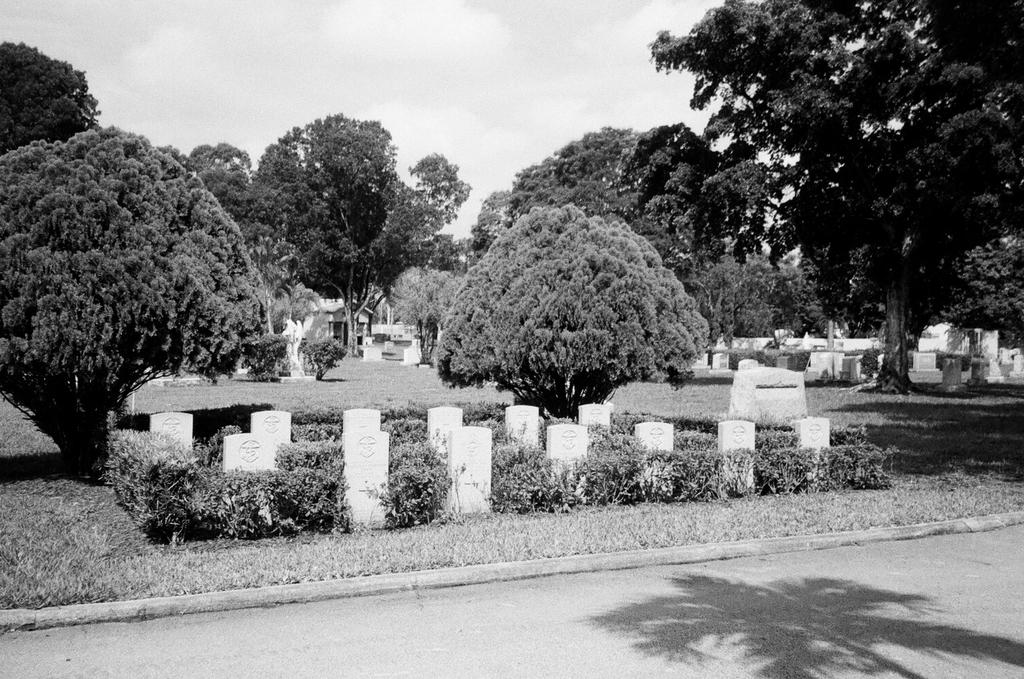What type of location is depicted in the image? There is a graveyard in the image. What can be found within the graveyard? There are graves in the graveyard. What type of vegetation is present in the image? There are plants, trees, and grass in the image. What is visible in the background of the image? The sky is visible in the image. How many pies are being served at the funeral in the image? There is no indication of a funeral or pies being served in the image. What type of net is being used to catch the birds in the image? There are no birds or nets present in the image. 